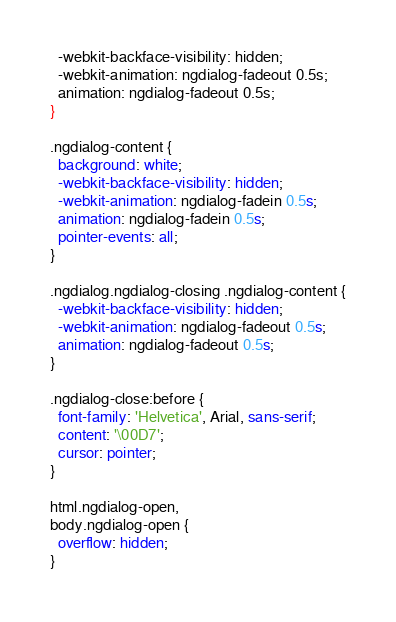Convert code to text. <code><loc_0><loc_0><loc_500><loc_500><_CSS_>  -webkit-backface-visibility: hidden;
  -webkit-animation: ngdialog-fadeout 0.5s;
  animation: ngdialog-fadeout 0.5s;
}

.ngdialog-content {
  background: white;
  -webkit-backface-visibility: hidden;
  -webkit-animation: ngdialog-fadein 0.5s;
  animation: ngdialog-fadein 0.5s;
  pointer-events: all;
}

.ngdialog.ngdialog-closing .ngdialog-content {
  -webkit-backface-visibility: hidden;
  -webkit-animation: ngdialog-fadeout 0.5s;
  animation: ngdialog-fadeout 0.5s;
}

.ngdialog-close:before {
  font-family: 'Helvetica', Arial, sans-serif;
  content: '\00D7';
  cursor: pointer;
}

html.ngdialog-open,
body.ngdialog-open {
  overflow: hidden;
}</code> 